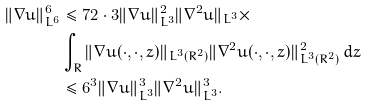<formula> <loc_0><loc_0><loc_500><loc_500>\| \nabla u \| _ { L ^ { 6 } } ^ { 6 } & \leq 7 2 \cdot 3 \| \nabla u \| _ { L ^ { 3 } } ^ { 2 } \| \nabla ^ { 2 } u \| _ { L ^ { 3 } } \times \\ & \int _ { R } \| \nabla u ( \cdot , \cdot , z ) \| _ { L ^ { 3 } ( R ^ { 2 } ) } \| \nabla ^ { 2 } u ( \cdot , \cdot , z ) \| _ { L ^ { 3 } ( R ^ { 2 } ) } ^ { 2 } \, d z \\ & \leq 6 ^ { 3 } \| \nabla u \| _ { L ^ { 3 } } ^ { 3 } \| \nabla ^ { 2 } u \| _ { L ^ { 3 } } ^ { 3 } .</formula> 